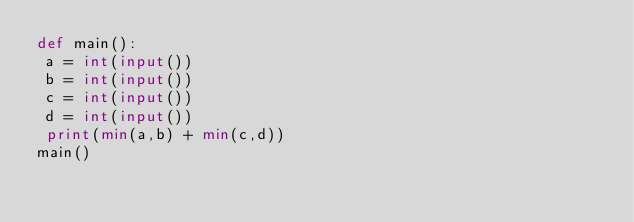Convert code to text. <code><loc_0><loc_0><loc_500><loc_500><_Python_>def main():
 a = int(input())
 b = int(input())
 c = int(input())
 d = int(input())
 print(min(a,b) + min(c,d))
main()</code> 